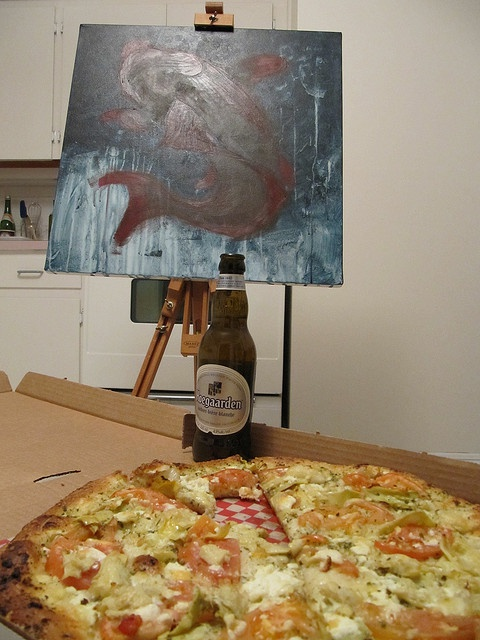Describe the objects in this image and their specific colors. I can see pizza in gray, tan, and olive tones and bottle in gray and black tones in this image. 